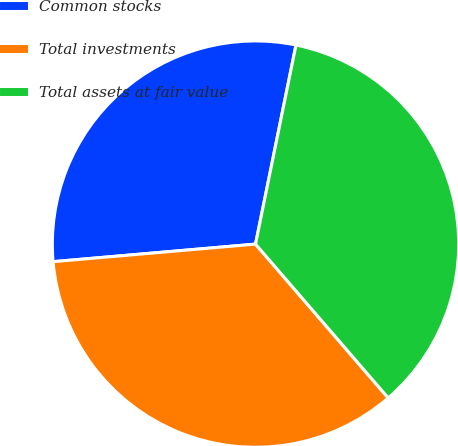Convert chart to OTSL. <chart><loc_0><loc_0><loc_500><loc_500><pie_chart><fcel>Common stocks<fcel>Total investments<fcel>Total assets at fair value<nl><fcel>29.57%<fcel>34.95%<fcel>35.48%<nl></chart> 